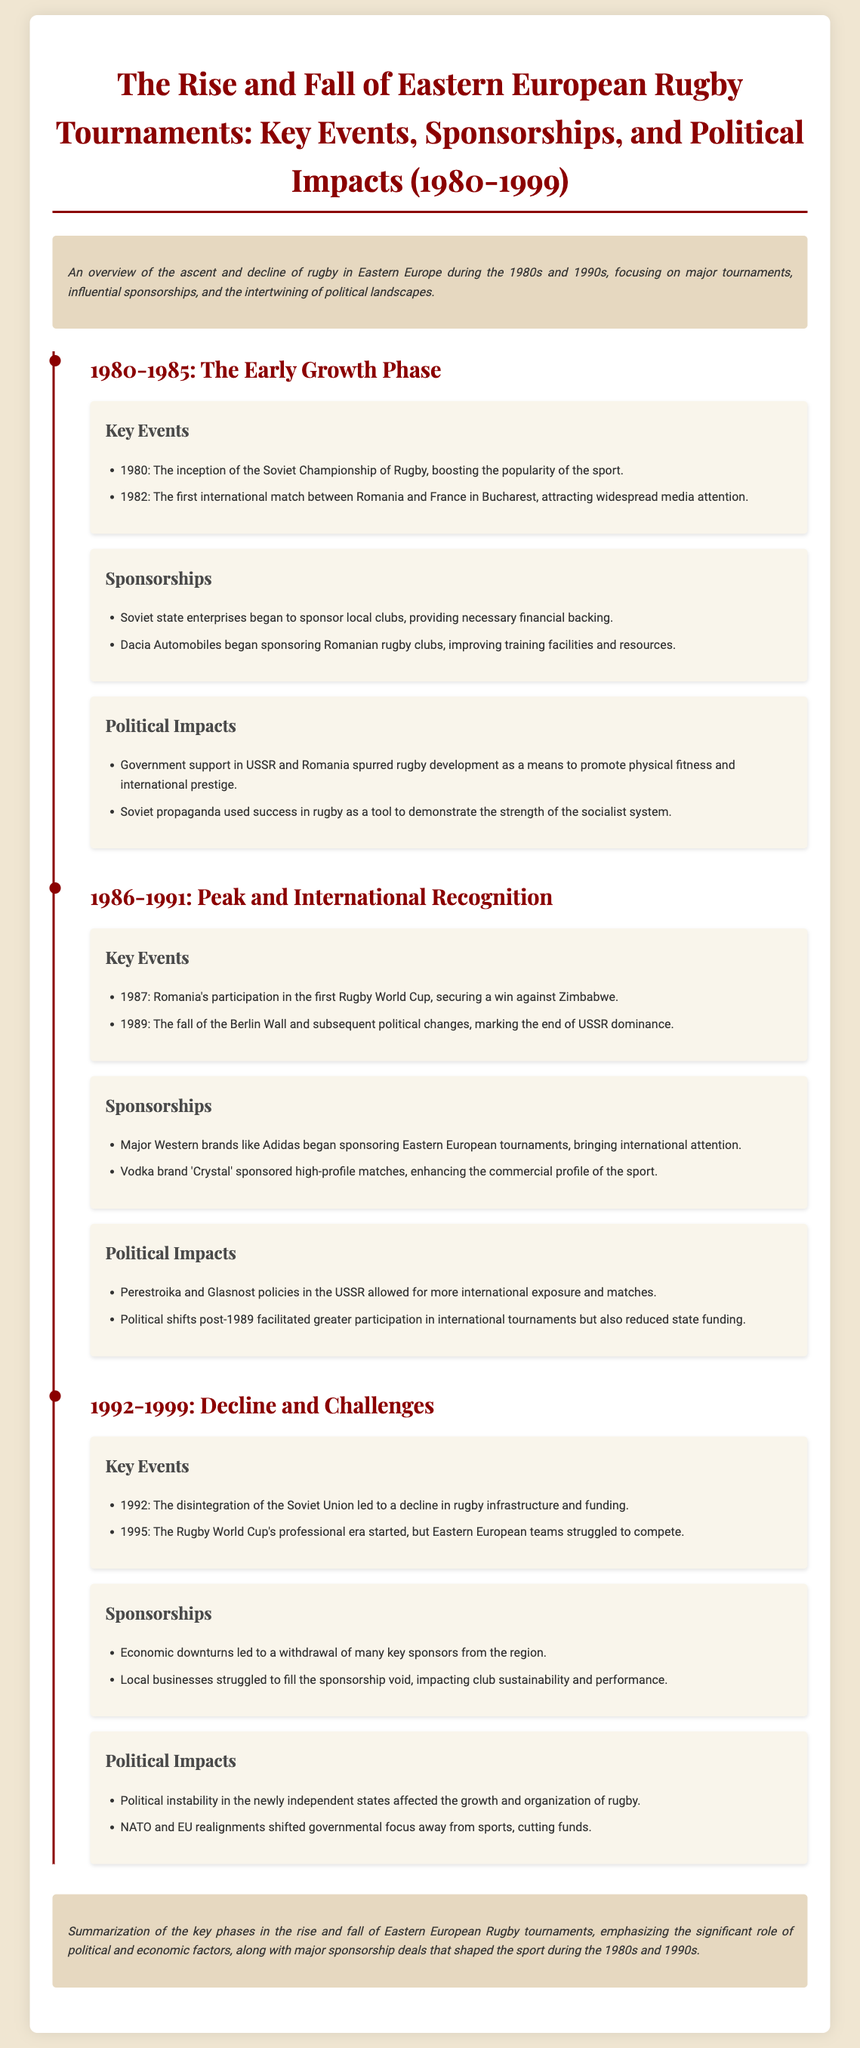What year was the Soviet Championship of Rugby initiated? The document states that the Soviet Championship of Rugby was initiated in 1980.
Answer: 1980 What major event happened in 1987 for Romanian rugby? The document mentions Romania's participation in the first Rugby World Cup and securing a win against Zimbabwe in 1987.
Answer: Rugby World Cup Which company sponsored Romanian rugby clubs in the early 1980s? Dacia Automobiles is indicated in the document as a sponsor of Romanian rugby clubs in the early 1980s.
Answer: Dacia Automobiles What political policy in the USSR allowed for more international exposure in rugby? The document refers to the Perestroika and Glasnost policies in the USSR that allowed for more international exposure and matches.
Answer: Perestroika and Glasnost What impact did the disintegration of the Soviet Union have on rugby? The document states that the disintegration of the Soviet Union in 1992 led to a decline in rugby infrastructure and funding.
Answer: Decline in infrastructure Which brand began sponsoring Eastern European tournaments in 1989? Major Western brands like Adidas began sponsoring Eastern European tournaments in 1989, according to the document.
Answer: Adidas What was the primary reason for the withdrawal of sponsors in the 1990s? The document states that economic downturns led to a withdrawal of many key sponsors from the region in the 1990s.
Answer: Economic downturns What did the fall of the Berlin Wall signify politically for rugby? The document mentions that the fall of the Berlin Wall in 1989 marked the end of USSR dominance, impacting rugby politics.
Answer: End of USSR dominance What overall trend does the document emphasize concerning Eastern European rugby from 1980 to 1999? The document outlines the rise and fall of Eastern European rugby tournaments, correlating it with political and economic factors.
Answer: Rise and fall 